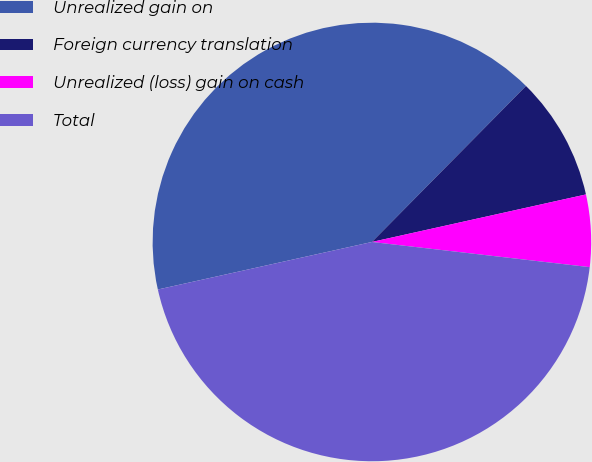Convert chart. <chart><loc_0><loc_0><loc_500><loc_500><pie_chart><fcel>Unrealized gain on<fcel>Foreign currency translation<fcel>Unrealized (loss) gain on cash<fcel>Total<nl><fcel>40.88%<fcel>9.12%<fcel>5.31%<fcel>44.69%<nl></chart> 